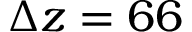Convert formula to latex. <formula><loc_0><loc_0><loc_500><loc_500>\Delta z = 6 6</formula> 